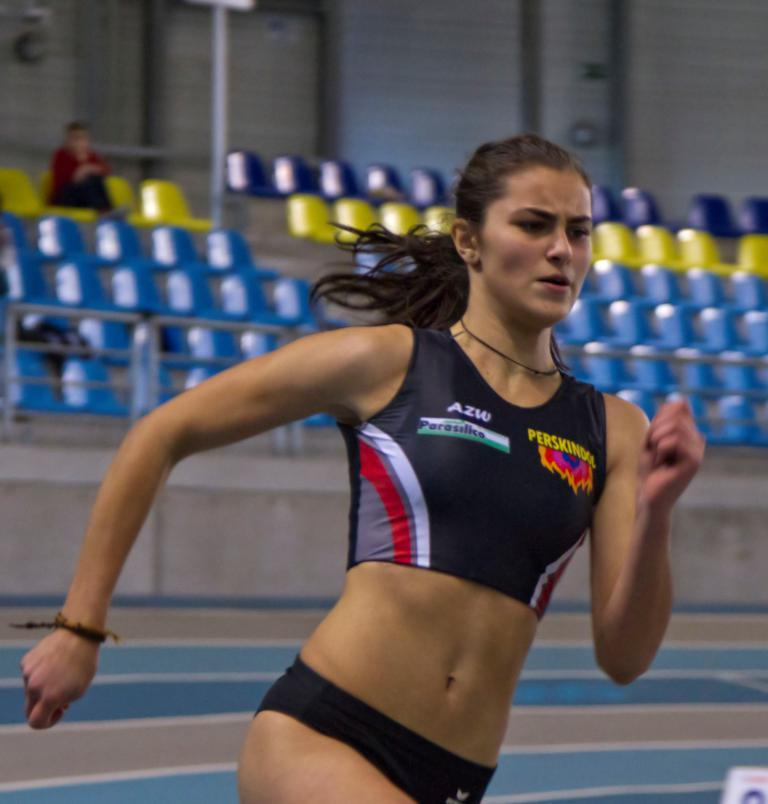<image>
Offer a succinct explanation of the picture presented. A woman with AZW on her uniform runs fast. 